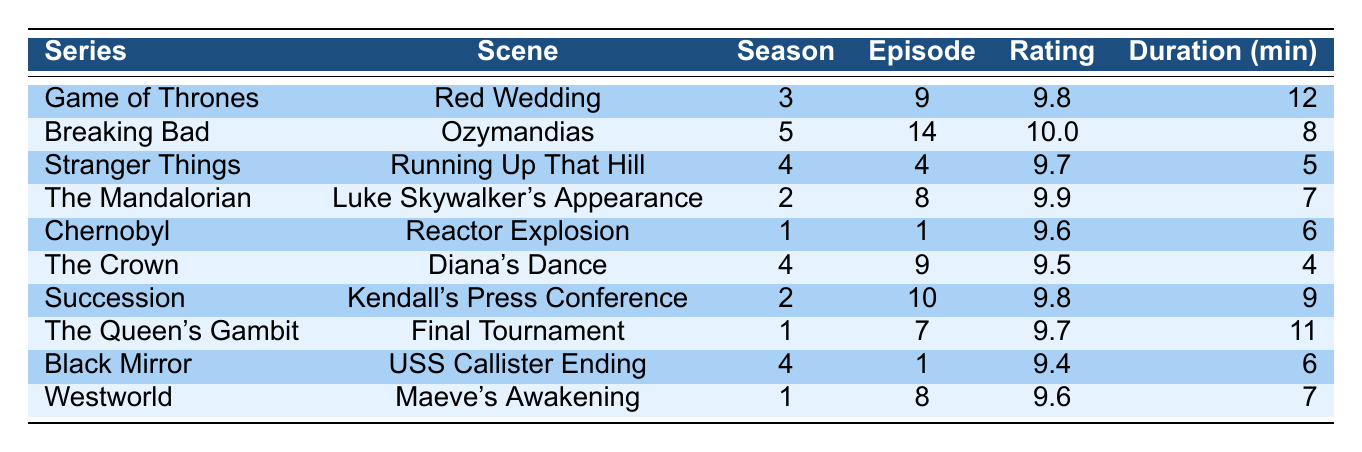What is the highest-rated scene in the table? The scene with the highest rating is "Ozymandias" from "Breaking Bad" with a rating of 10.0.
Answer: 10.0 Which scene has the longest duration? The scene "Red Wedding" from "Game of Thrones" has the longest duration at 12 minutes.
Answer: 12 How many scenes have a rating above 9.5? The scenes that have ratings over 9.5 are "Ozymandias," "Red Wedding," "Luke Skywalker's Appearance," "Kendall's Press Conference," "Running Up That Hill," and "Final Tournament." This totals six scenes.
Answer: 6 What is the average rating of all the scenes listed? The sum of ratings is (9.8 + 10.0 + 9.7 + 9.9 + 9.6 + 9.5 + 9.8 + 9.7 + 9.4 + 9.6) = 97.6, and there are 10 scenes, so the average rating is 97.6 / 10 = 9.76.
Answer: 9.76 Is there a scene that lasts exactly 6 minutes? Yes, both "Reactor Explosion" from "Chernobyl" and "USS Callister Ending" from "Black Mirror" last exactly 6 minutes.
Answer: Yes Which series has the most highly rated scene and what is that rating? The series "Breaking Bad" contains the highest-rated scene, "Ozymandias," which has a rating of 10.0.
Answer: Breaking Bad, 10.0 How many scenes are from the same season? The scenes "Kendall's Press Conference" from "Succession" and "Luke Skywalker's Appearance" from "The Mandalorian" are both from season 2, but they are from different series. No scenes are from the same season.
Answer: 0 What is the total duration of the top three rated scenes? The top three scenes by rating are "Ozymandias" (8 min), "Luke Skywalker's Appearance" (7 min), and "Red Wedding" (12 min). Summing these gives 8 + 7 + 12 = 27 minutes.
Answer: 27 Which scene has a rating closest to 9.5? The scene "Diana's Dance" from "The Crown" has a rating of 9.5, which is the same.
Answer: Diana's Dance Are there any scenes with a rating lower than 9.5? Yes, "USS Callister Ending" has a rating of 9.4, which is lower than 9.5.
Answer: Yes 